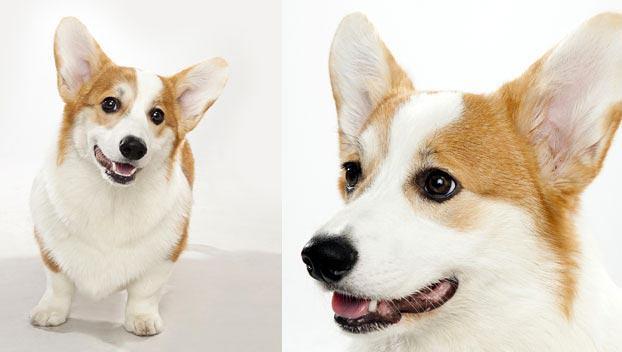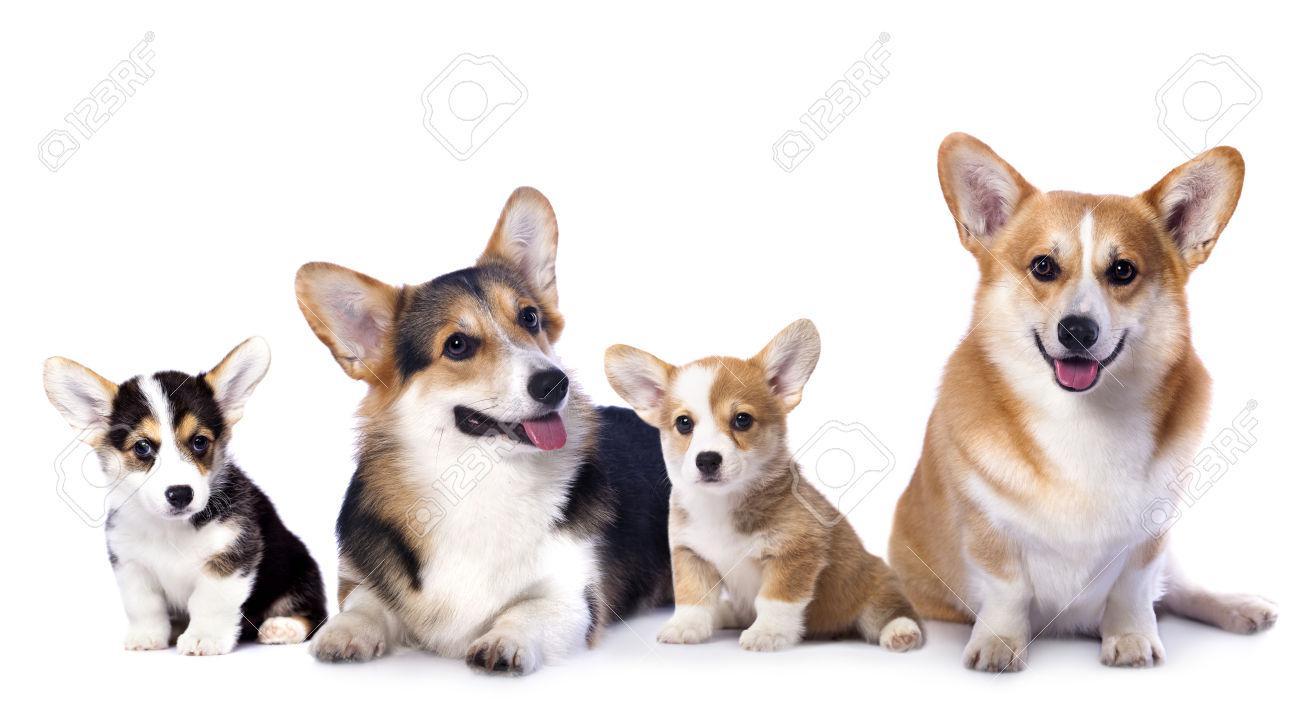The first image is the image on the left, the second image is the image on the right. For the images displayed, is the sentence "One image has exactly one dog." factually correct? Answer yes or no. No. The first image is the image on the left, the second image is the image on the right. For the images displayed, is the sentence "There are three dogs" factually correct? Answer yes or no. No. 